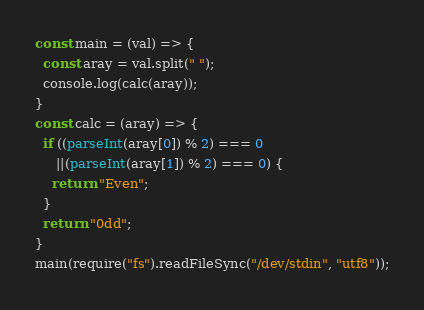<code> <loc_0><loc_0><loc_500><loc_500><_JavaScript_>const main = (val) => {
  const aray = val.split(" ");
  console.log(calc(aray));
}
const calc = (aray) => {
  if ((parseInt(aray[0]) % 2) === 0
     ||(parseInt(aray[1]) % 2) === 0) {
    return "Even";
  }
  return "0dd";
}
main(require("fs").readFileSync("/dev/stdin", "utf8"));</code> 